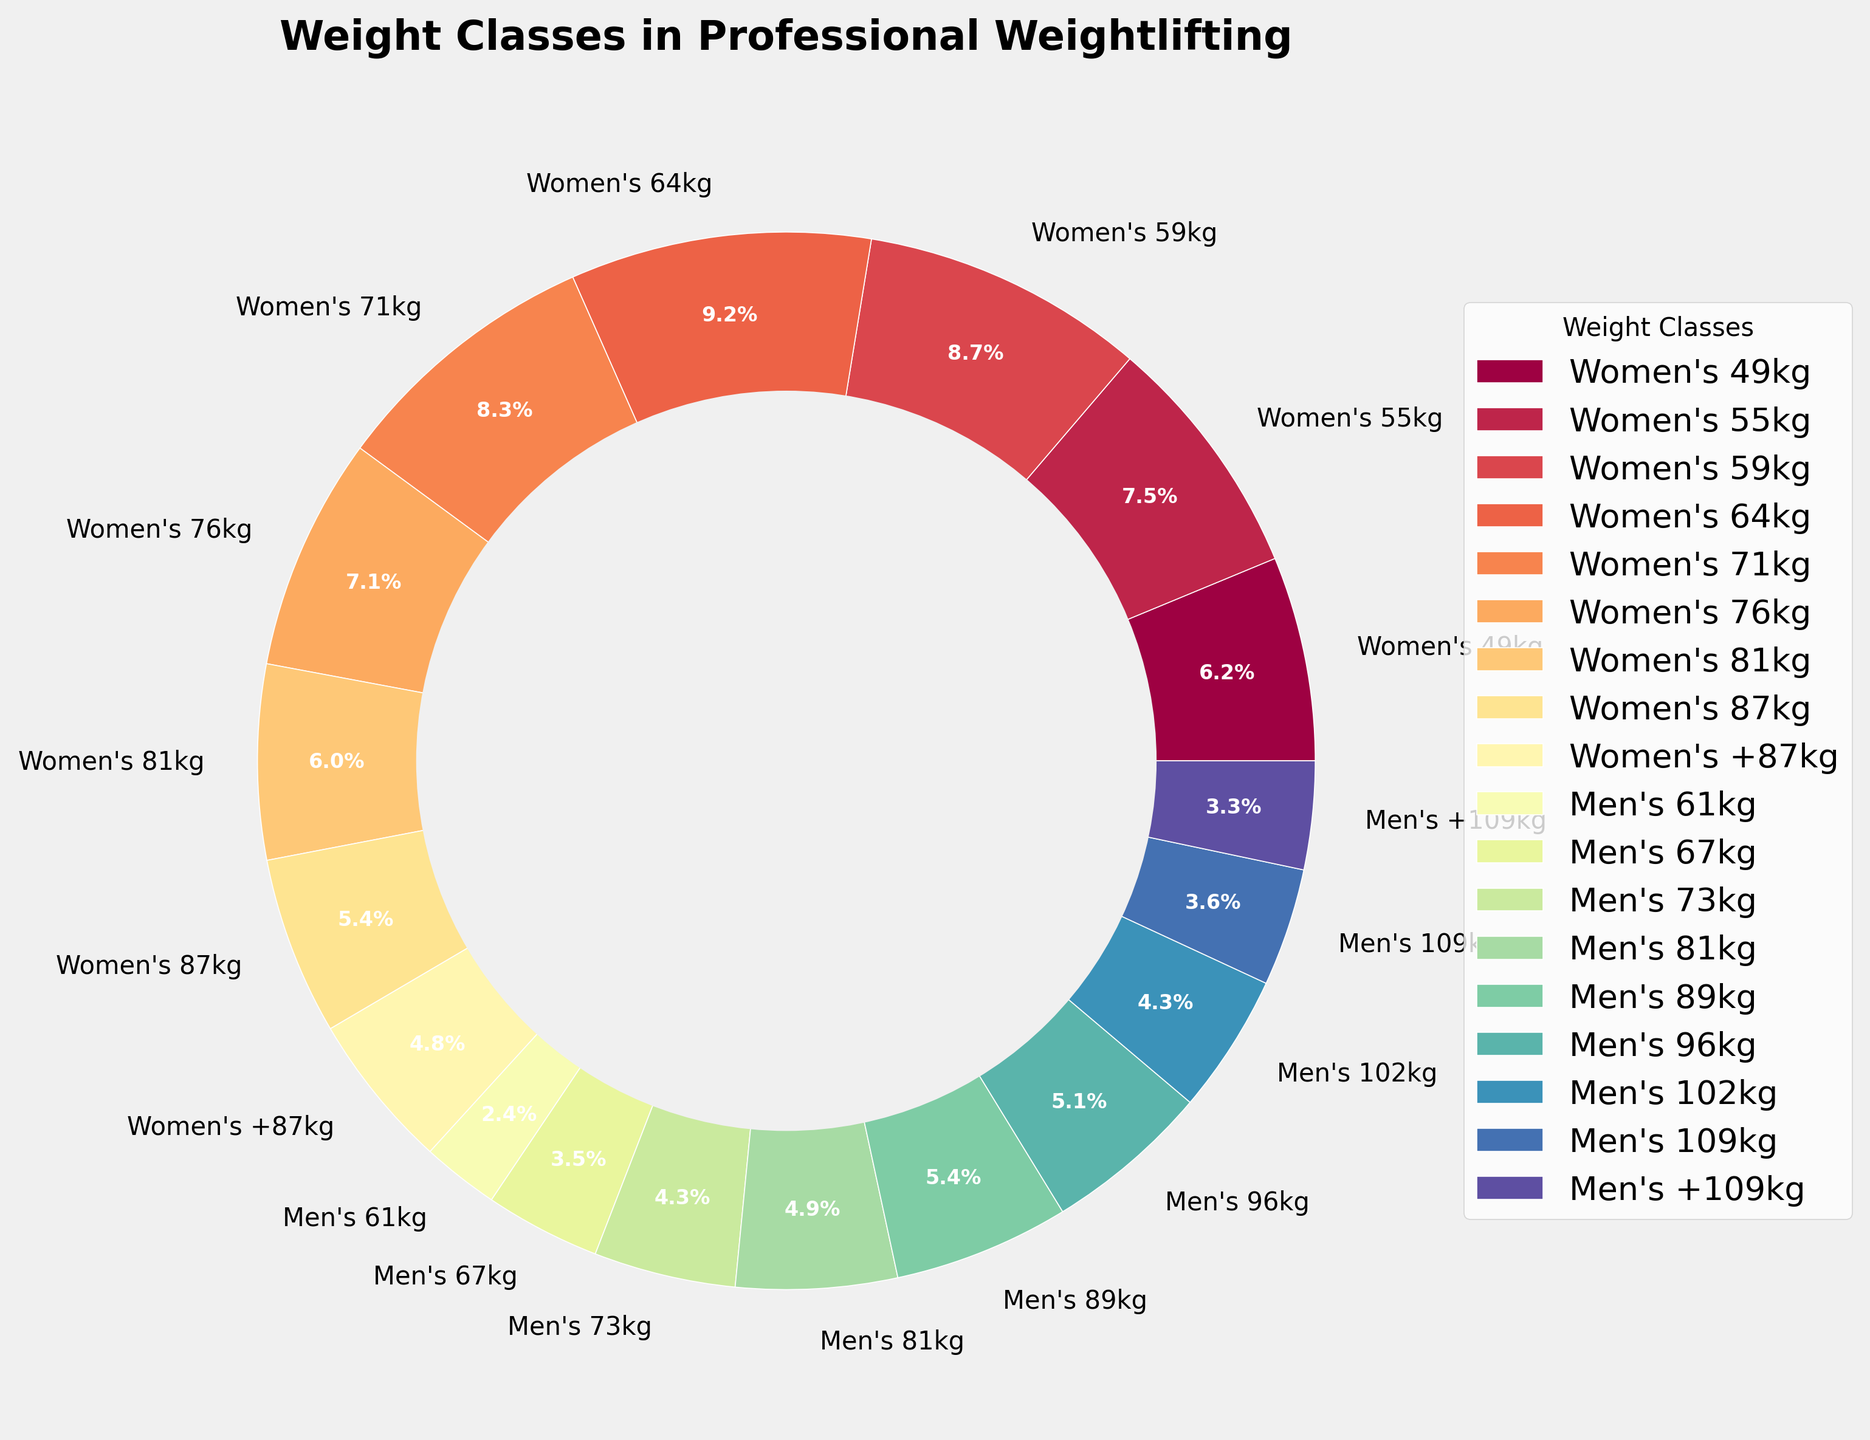Which women's weight class has the highest percentage? By visually inspecting the pie chart, we identify that the largest segment among the women's weight classes corresponds to the Women's 64kg category.
Answer: Women's 64kg Which men's weight class has the smallest percentage? By examining the pie chart sections for the men's categories, we can see that the Men's 61kg category has the smallest segment.
Answer: Men's 61kg What is the combined percentage of Women's 64kg and Men's 81kg weight classes? By adding up the percentages for Women's 64kg (12.5%) and Men's 81kg (6.7%), we get 12.5 + 6.7 = 19.2%.
Answer: 19.2% Is the percentage of Women's 64kg class greater than the combined percentage of Men's 61kg and Men's 67kg classes? The percentage for Women's 64kg is 12.5%. For Men's 61kg and Men's 67kg, we add 3.2% and 4.8% which equals 8%. Since 12.5% is greater than 8%, the Women's 64kg class has a higher percentage.
Answer: Yes Which weight classes are represented with pink and yellow colors in the chart? Inspect the chart and observe which sections are colored pink and yellow. Pink corresponds to Women's 64kg and yellow to Women's 49kg.
Answer: Women's 64kg, Women's 49kg What percentage of total do the weight classes at or above 87kg in both men's and women's categories represent? Add the percentages for Women's 87kg and +87kg (7.4% + 6.5%) and Men's 109kg and +109kg (4.9% + 4.5%). The sum is 7.4 + 6.5 + 4.9 + 4.5 = 23.3%.
Answer: 23.3% Which weight class segments appear with the thinnest slices, and what are their percentages? The segments for Men's 61kg and Women's +87kg are visually the thinnest, respectively. They have percentages of 3.2% and 6.5%.
Answer: Men's 61kg (3.2%), Women's +87kg (6.5%) How does the percentage of the Women's 81kg class compare to the Men's 96kg class? The percentage for Women's 81kg is 8.1%, and for Men's 96kg it is 6.9%. By comparing these values, we see that the Women’s 81kg class has a higher percentage.
Answer: Women's 81kg > Men's 96kg What is the difference in percentage between Women's 55kg and Women's 87kg classes? Subtract the percentage of Women's 87kg (7.4%) from that of Women's 55kg (10.2%). The difference is 10.2 - 7.4 = 2.8%.
Answer: 2.8% Name the weight class that is located just to the left of the Women's 71kg on the chart. Inspect the position of the Women's 71kg segment and see which segment is immediately to its left. It corresponds to Women's 64kg.
Answer: Women's 64kg 